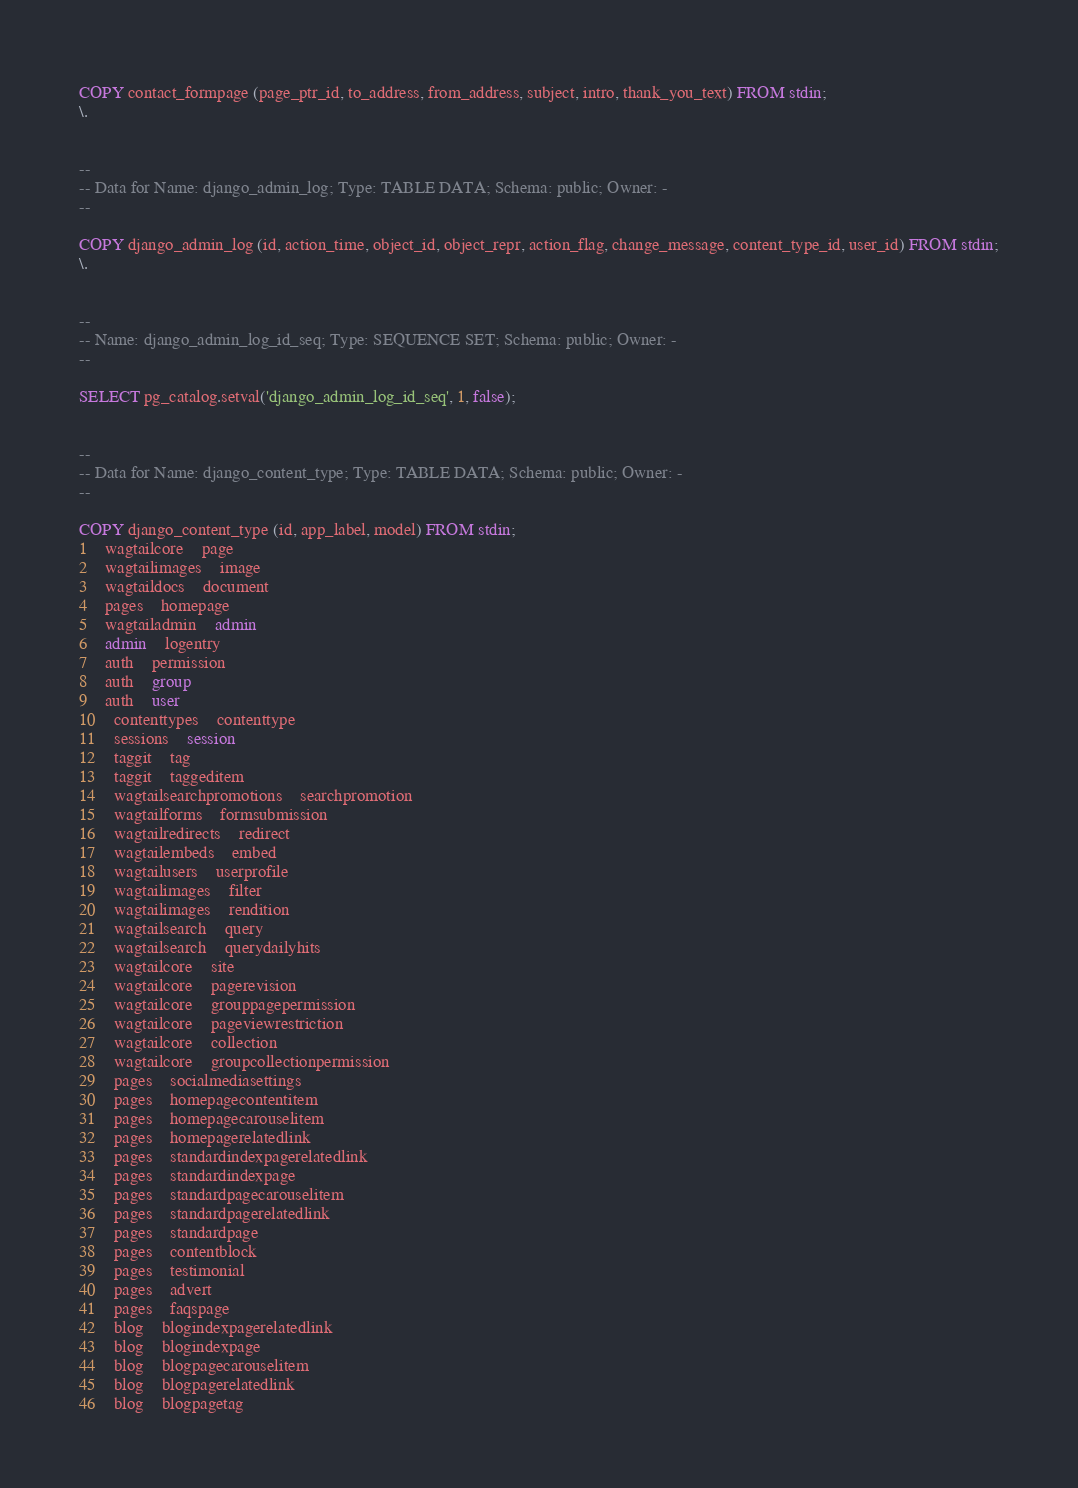<code> <loc_0><loc_0><loc_500><loc_500><_SQL_>COPY contact_formpage (page_ptr_id, to_address, from_address, subject, intro, thank_you_text) FROM stdin;
\.


--
-- Data for Name: django_admin_log; Type: TABLE DATA; Schema: public; Owner: -
--

COPY django_admin_log (id, action_time, object_id, object_repr, action_flag, change_message, content_type_id, user_id) FROM stdin;
\.


--
-- Name: django_admin_log_id_seq; Type: SEQUENCE SET; Schema: public; Owner: -
--

SELECT pg_catalog.setval('django_admin_log_id_seq', 1, false);


--
-- Data for Name: django_content_type; Type: TABLE DATA; Schema: public; Owner: -
--

COPY django_content_type (id, app_label, model) FROM stdin;
1	wagtailcore	page
2	wagtailimages	image
3	wagtaildocs	document
4	pages	homepage
5	wagtailadmin	admin
6	admin	logentry
7	auth	permission
8	auth	group
9	auth	user
10	contenttypes	contenttype
11	sessions	session
12	taggit	tag
13	taggit	taggeditem
14	wagtailsearchpromotions	searchpromotion
15	wagtailforms	formsubmission
16	wagtailredirects	redirect
17	wagtailembeds	embed
18	wagtailusers	userprofile
19	wagtailimages	filter
20	wagtailimages	rendition
21	wagtailsearch	query
22	wagtailsearch	querydailyhits
23	wagtailcore	site
24	wagtailcore	pagerevision
25	wagtailcore	grouppagepermission
26	wagtailcore	pageviewrestriction
27	wagtailcore	collection
28	wagtailcore	groupcollectionpermission
29	pages	socialmediasettings
30	pages	homepagecontentitem
31	pages	homepagecarouselitem
32	pages	homepagerelatedlink
33	pages	standardindexpagerelatedlink
34	pages	standardindexpage
35	pages	standardpagecarouselitem
36	pages	standardpagerelatedlink
37	pages	standardpage
38	pages	contentblock
39	pages	testimonial
40	pages	advert
41	pages	faqspage
42	blog	blogindexpagerelatedlink
43	blog	blogindexpage
44	blog	blogpagecarouselitem
45	blog	blogpagerelatedlink
46	blog	blogpagetag</code> 